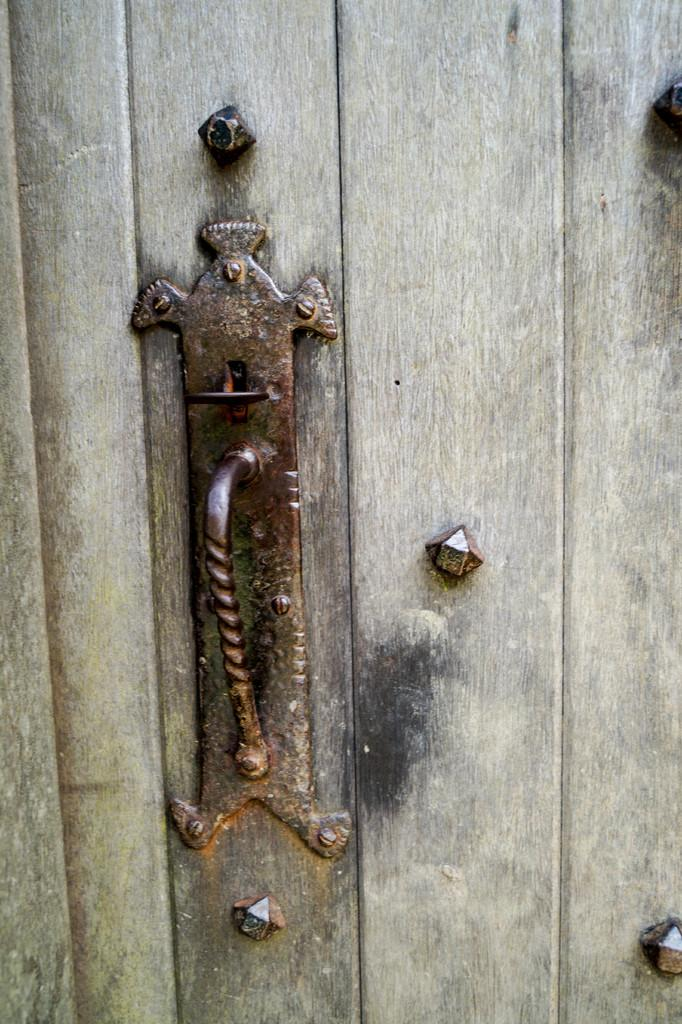What type of door is visible in the image? There is a wooden door in the image. What material is the handle made of on the door? The handle on the door is made of metal. What type of celery is being used by the minister in the image? There is no minister or celery present in the image. 